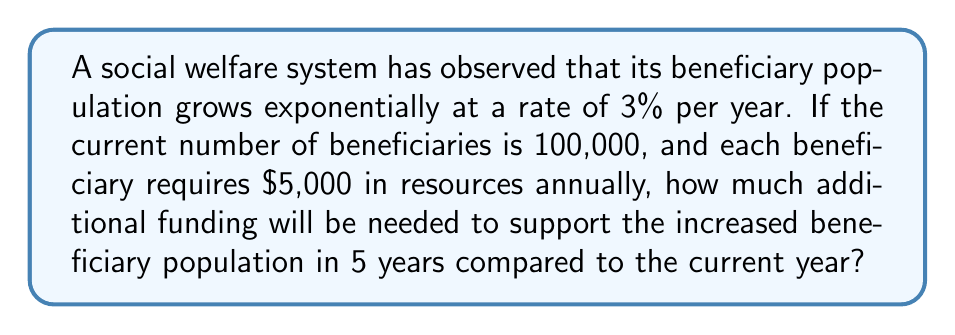Can you solve this math problem? Let's approach this step-by-step:

1) First, we need to calculate the number of beneficiaries after 5 years. We can use the exponential growth formula:

   $A = P(1 + r)^t$

   Where:
   $A$ = Final amount
   $P$ = Initial principal balance
   $r$ = Annual growth rate (in decimal form)
   $t$ = Number of years

2) Plugging in our values:
   $A = 100,000(1 + 0.03)^5$

3) Calculate:
   $A = 100,000(1.03)^5 = 100,000(1.159274) \approx 115,927$

4) Now we know that in 5 years, there will be approximately 115,927 beneficiaries.

5) Calculate the current annual resource requirement:
   $100,000 \times \$5,000 = \$500,000,000$

6) Calculate the annual resource requirement in 5 years:
   $115,927 \times \$5,000 = \$579,635,000$

7) The additional funding needed is the difference between these two amounts:
   $\$579,635,000 - \$500,000,000 = \$79,635,000$
Answer: $\$79,635,000 